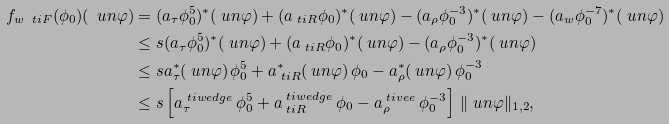<formula> <loc_0><loc_0><loc_500><loc_500>f _ { w \ t i F } ( \phi _ { 0 } ) ( \ u n \varphi ) & = ( a _ { \tau } \phi _ { 0 } ^ { 5 } ) ^ { * } ( \ u n \varphi ) + ( a _ { \ t i R } \phi _ { 0 } ) ^ { * } ( \ u n \varphi ) - ( a _ { \rho } \phi _ { 0 } ^ { - 3 } ) ^ { * } ( \ u n \varphi ) - ( a _ { w } \phi _ { 0 } ^ { - 7 } ) ^ { * } ( \ u n \varphi ) \\ & \leq s ( a _ { \tau } \phi _ { 0 } ^ { 5 } ) ^ { * } ( \ u n \varphi ) + ( a _ { \ t i R } \phi _ { 0 } ) ^ { * } ( \ u n \varphi ) - ( a _ { \rho } \phi _ { 0 } ^ { - 3 } ) ^ { * } ( \ u n \varphi ) \\ & \leq s a _ { \tau } ^ { * } ( \ u n \varphi ) \, \phi _ { 0 } ^ { 5 } + a _ { \ t i R } ^ { * } ( \ u n \varphi ) \, \phi _ { 0 } - a _ { \rho } ^ { * } ( \ u n \varphi ) \, \phi _ { 0 } ^ { - 3 } \\ & \leq s \left [ a _ { \tau } ^ { \ t i w e d g e } \, \phi _ { 0 } ^ { 5 } + a _ { \ t i R } ^ { \ t i w e d g e } \, \phi _ { 0 } - a _ { \rho } ^ { \ t i v e e } \, \phi _ { 0 } ^ { - 3 } \right ] \, \| \ u n \varphi \| _ { 1 , 2 } ,</formula> 